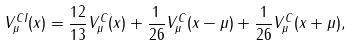Convert formula to latex. <formula><loc_0><loc_0><loc_500><loc_500>V _ { \mu } ^ { C I } ( x ) = \frac { 1 2 } { 1 3 } V _ { \mu } ^ { C } ( x ) + \frac { 1 } { 2 6 } V _ { \mu } ^ { C } ( x - \mu ) + \frac { 1 } { 2 6 } V _ { \mu } ^ { C } ( x + \mu ) ,</formula> 